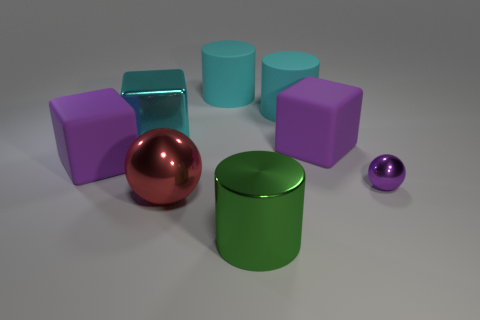Subtract all cyan spheres. How many purple blocks are left? 2 Subtract all big cyan rubber cylinders. How many cylinders are left? 1 Add 1 cyan matte blocks. How many objects exist? 9 Subtract all balls. How many objects are left? 6 Subtract all gray cylinders. Subtract all yellow cubes. How many cylinders are left? 3 Add 4 cubes. How many cubes are left? 7 Add 2 big cyan cylinders. How many big cyan cylinders exist? 4 Subtract 0 blue spheres. How many objects are left? 8 Subtract all matte cylinders. Subtract all red shiny things. How many objects are left? 5 